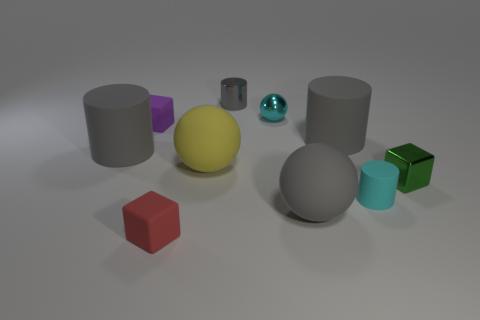Is the size of the gray matte sphere the same as the cube right of the metal cylinder?
Offer a terse response. No. Is the number of tiny objects behind the cyan metallic ball less than the number of purple matte objects behind the tiny purple cube?
Offer a very short reply. No. How big is the ball right of the small shiny ball?
Your answer should be very brief. Large. Is the purple matte thing the same size as the yellow matte ball?
Give a very brief answer. No. What number of small things are in front of the green cube and on the left side of the tiny gray metallic object?
Your response must be concise. 1. What number of red things are either things or tiny objects?
Offer a terse response. 1. How many rubber things are either tiny red things or big yellow objects?
Your answer should be very brief. 2. Are there any cyan rubber things?
Make the answer very short. Yes. Is the tiny gray thing the same shape as the tiny cyan matte object?
Offer a very short reply. Yes. There is a small gray metal cylinder behind the big gray matte cylinder to the left of the small red rubber block; how many tiny red objects are in front of it?
Ensure brevity in your answer.  1. 